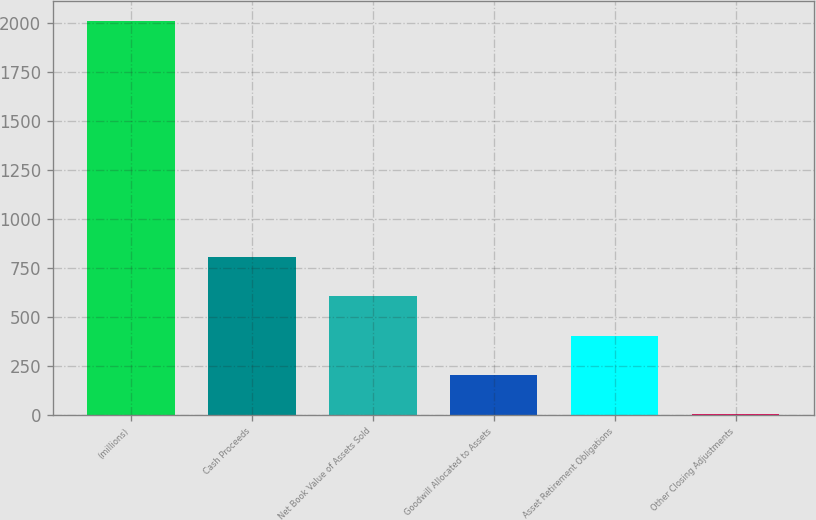Convert chart. <chart><loc_0><loc_0><loc_500><loc_500><bar_chart><fcel>(millions)<fcel>Cash Proceeds<fcel>Net Book Value of Assets Sold<fcel>Goodwill Allocated to Assets<fcel>Asset Retirement Obligations<fcel>Other Closing Adjustments<nl><fcel>2013<fcel>807<fcel>606<fcel>204<fcel>405<fcel>3<nl></chart> 